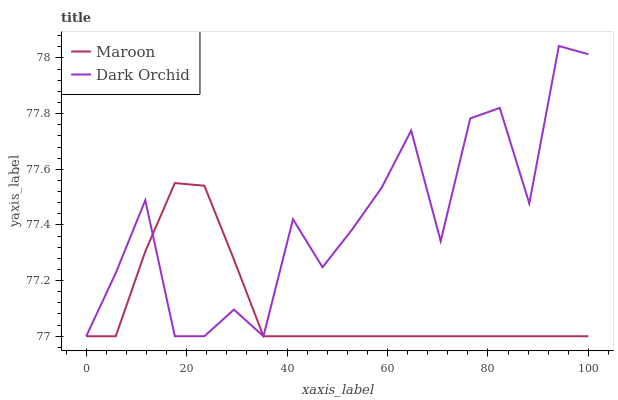Does Maroon have the minimum area under the curve?
Answer yes or no. Yes. Does Dark Orchid have the maximum area under the curve?
Answer yes or no. Yes. Does Maroon have the maximum area under the curve?
Answer yes or no. No. Is Maroon the smoothest?
Answer yes or no. Yes. Is Dark Orchid the roughest?
Answer yes or no. Yes. Is Maroon the roughest?
Answer yes or no. No. Does Maroon have the highest value?
Answer yes or no. No. 